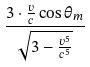Convert formula to latex. <formula><loc_0><loc_0><loc_500><loc_500>\frac { 3 \cdot \frac { v } { c } \cos \theta _ { m } } { \sqrt { 3 - \frac { v ^ { 5 } } { c ^ { 5 } } } }</formula> 